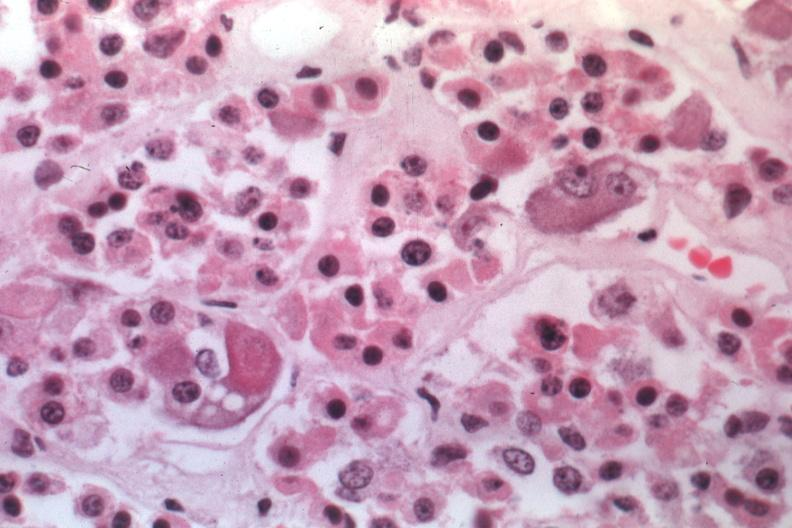what is present?
Answer the question using a single word or phrase. Pituitary 